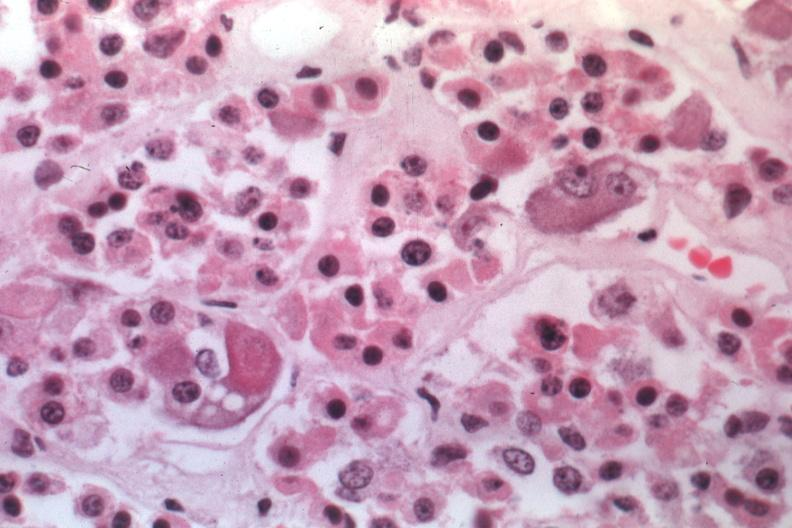what is present?
Answer the question using a single word or phrase. Pituitary 